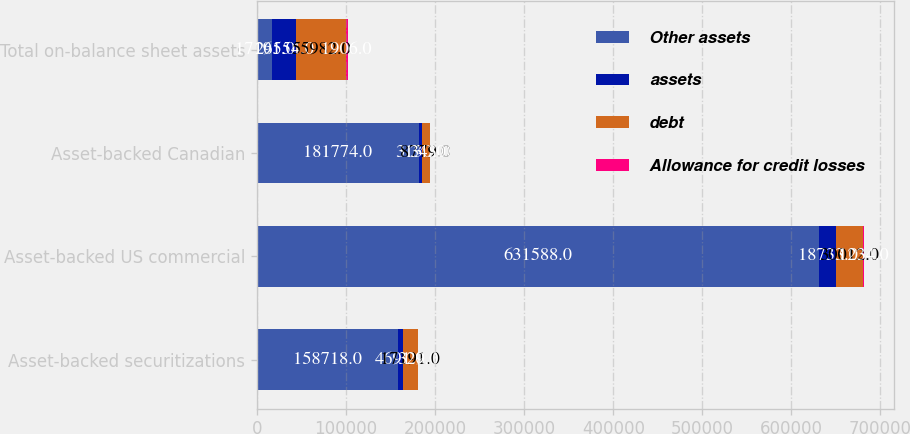Convert chart. <chart><loc_0><loc_0><loc_500><loc_500><stacked_bar_chart><ecel><fcel>Asset-backed securitizations<fcel>Asset-backed US commercial<fcel>Asset-backed Canadian<fcel>Total on-balance sheet assets<nl><fcel>Other assets<fcel>158718<fcel>631588<fcel>181774<fcel>17191<nl><fcel>assets<fcel>4691<fcel>18733<fcel>3130<fcel>26554<nl><fcel>debt<fcel>17191<fcel>30012<fcel>8779<fcel>55982<nl><fcel>Allowance for credit losses<fcel>329<fcel>1234<fcel>343<fcel>1906<nl></chart> 